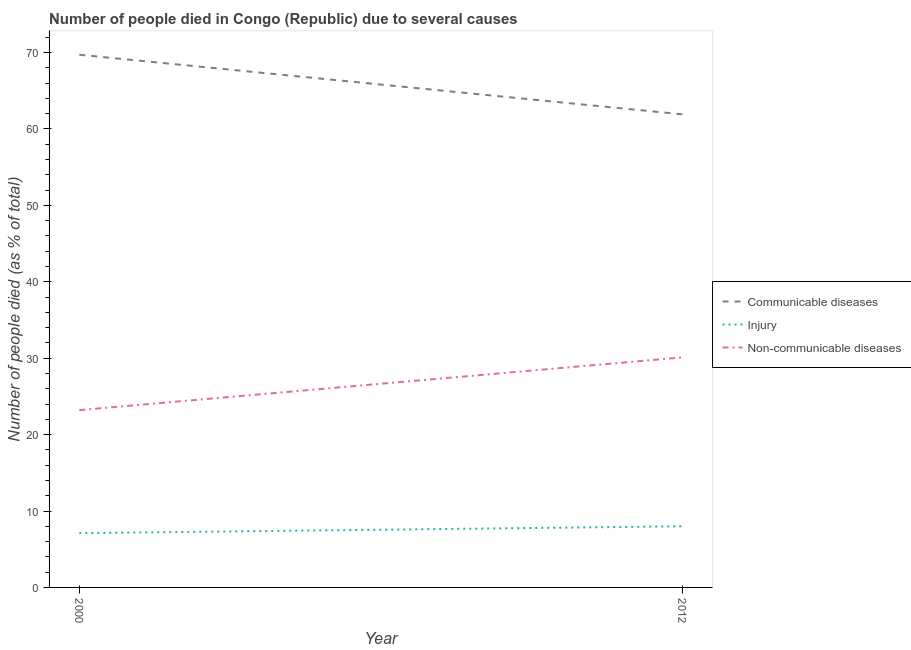Does the line corresponding to number of people who died of injury intersect with the line corresponding to number of people who died of communicable diseases?
Provide a short and direct response. No. Is the number of lines equal to the number of legend labels?
Provide a succinct answer. Yes. What is the number of people who dies of non-communicable diseases in 2000?
Your response must be concise. 23.2. Across all years, what is the maximum number of people who died of communicable diseases?
Offer a terse response. 69.7. Across all years, what is the minimum number of people who died of injury?
Provide a short and direct response. 7.1. In which year was the number of people who died of injury minimum?
Offer a terse response. 2000. What is the difference between the number of people who dies of non-communicable diseases in 2000 and that in 2012?
Your answer should be compact. -6.9. What is the difference between the number of people who died of injury in 2012 and the number of people who died of communicable diseases in 2000?
Offer a terse response. -61.7. What is the average number of people who dies of non-communicable diseases per year?
Your answer should be compact. 26.65. In the year 2000, what is the difference between the number of people who died of communicable diseases and number of people who dies of non-communicable diseases?
Offer a very short reply. 46.5. What is the ratio of the number of people who died of injury in 2000 to that in 2012?
Your answer should be compact. 0.89. Is the number of people who dies of non-communicable diseases in 2000 less than that in 2012?
Provide a succinct answer. Yes. Is it the case that in every year, the sum of the number of people who died of communicable diseases and number of people who died of injury is greater than the number of people who dies of non-communicable diseases?
Provide a short and direct response. Yes. Does the number of people who died of injury monotonically increase over the years?
Provide a succinct answer. Yes. Is the number of people who died of communicable diseases strictly greater than the number of people who died of injury over the years?
Give a very brief answer. Yes. How many lines are there?
Keep it short and to the point. 3. How many years are there in the graph?
Offer a terse response. 2. What is the difference between two consecutive major ticks on the Y-axis?
Your answer should be very brief. 10. Are the values on the major ticks of Y-axis written in scientific E-notation?
Keep it short and to the point. No. What is the title of the graph?
Keep it short and to the point. Number of people died in Congo (Republic) due to several causes. Does "Domestic" appear as one of the legend labels in the graph?
Offer a terse response. No. What is the label or title of the Y-axis?
Offer a terse response. Number of people died (as % of total). What is the Number of people died (as % of total) of Communicable diseases in 2000?
Give a very brief answer. 69.7. What is the Number of people died (as % of total) in Non-communicable diseases in 2000?
Provide a short and direct response. 23.2. What is the Number of people died (as % of total) of Communicable diseases in 2012?
Your answer should be compact. 61.9. What is the Number of people died (as % of total) of Non-communicable diseases in 2012?
Your response must be concise. 30.1. Across all years, what is the maximum Number of people died (as % of total) of Communicable diseases?
Provide a short and direct response. 69.7. Across all years, what is the maximum Number of people died (as % of total) of Non-communicable diseases?
Your answer should be very brief. 30.1. Across all years, what is the minimum Number of people died (as % of total) of Communicable diseases?
Ensure brevity in your answer.  61.9. Across all years, what is the minimum Number of people died (as % of total) of Non-communicable diseases?
Ensure brevity in your answer.  23.2. What is the total Number of people died (as % of total) of Communicable diseases in the graph?
Your answer should be very brief. 131.6. What is the total Number of people died (as % of total) in Injury in the graph?
Your response must be concise. 15.1. What is the total Number of people died (as % of total) in Non-communicable diseases in the graph?
Your answer should be compact. 53.3. What is the difference between the Number of people died (as % of total) in Communicable diseases in 2000 and that in 2012?
Offer a very short reply. 7.8. What is the difference between the Number of people died (as % of total) of Injury in 2000 and that in 2012?
Make the answer very short. -0.9. What is the difference between the Number of people died (as % of total) in Communicable diseases in 2000 and the Number of people died (as % of total) in Injury in 2012?
Make the answer very short. 61.7. What is the difference between the Number of people died (as % of total) in Communicable diseases in 2000 and the Number of people died (as % of total) in Non-communicable diseases in 2012?
Ensure brevity in your answer.  39.6. What is the difference between the Number of people died (as % of total) in Injury in 2000 and the Number of people died (as % of total) in Non-communicable diseases in 2012?
Provide a short and direct response. -23. What is the average Number of people died (as % of total) in Communicable diseases per year?
Provide a short and direct response. 65.8. What is the average Number of people died (as % of total) in Injury per year?
Provide a short and direct response. 7.55. What is the average Number of people died (as % of total) of Non-communicable diseases per year?
Ensure brevity in your answer.  26.65. In the year 2000, what is the difference between the Number of people died (as % of total) of Communicable diseases and Number of people died (as % of total) of Injury?
Provide a short and direct response. 62.6. In the year 2000, what is the difference between the Number of people died (as % of total) of Communicable diseases and Number of people died (as % of total) of Non-communicable diseases?
Give a very brief answer. 46.5. In the year 2000, what is the difference between the Number of people died (as % of total) of Injury and Number of people died (as % of total) of Non-communicable diseases?
Your answer should be compact. -16.1. In the year 2012, what is the difference between the Number of people died (as % of total) in Communicable diseases and Number of people died (as % of total) in Injury?
Your response must be concise. 53.9. In the year 2012, what is the difference between the Number of people died (as % of total) of Communicable diseases and Number of people died (as % of total) of Non-communicable diseases?
Offer a terse response. 31.8. In the year 2012, what is the difference between the Number of people died (as % of total) of Injury and Number of people died (as % of total) of Non-communicable diseases?
Provide a succinct answer. -22.1. What is the ratio of the Number of people died (as % of total) of Communicable diseases in 2000 to that in 2012?
Ensure brevity in your answer.  1.13. What is the ratio of the Number of people died (as % of total) of Injury in 2000 to that in 2012?
Your response must be concise. 0.89. What is the ratio of the Number of people died (as % of total) of Non-communicable diseases in 2000 to that in 2012?
Provide a succinct answer. 0.77. What is the difference between the highest and the lowest Number of people died (as % of total) of Communicable diseases?
Ensure brevity in your answer.  7.8. What is the difference between the highest and the lowest Number of people died (as % of total) in Injury?
Provide a succinct answer. 0.9. 